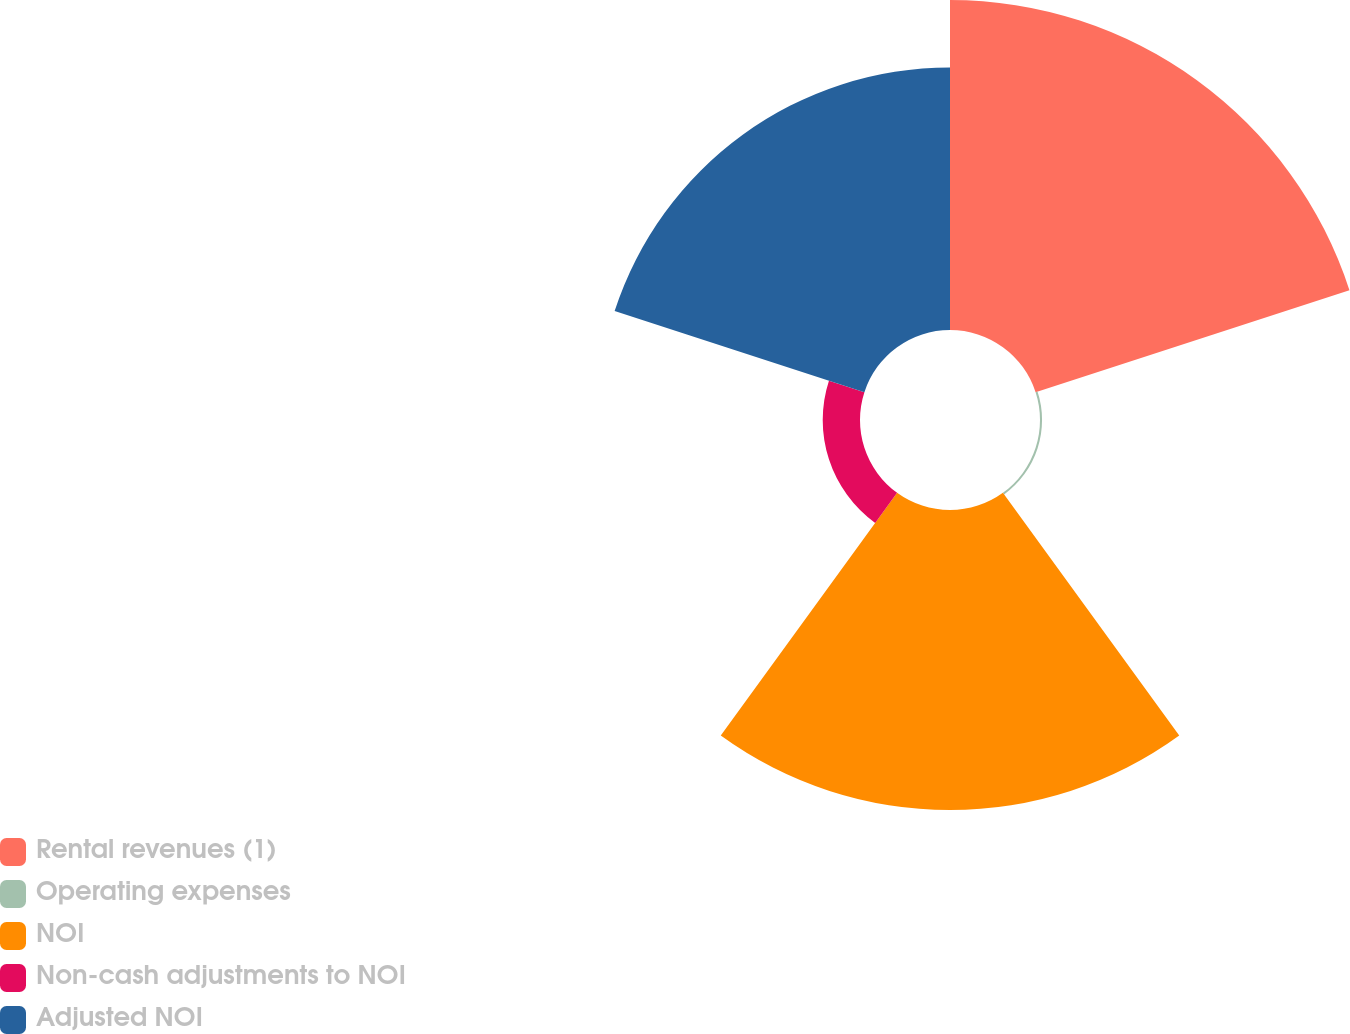Convert chart to OTSL. <chart><loc_0><loc_0><loc_500><loc_500><pie_chart><fcel>Rental revenues (1)<fcel>Operating expenses<fcel>NOI<fcel>Non-cash adjustments to NOI<fcel>Adjusted NOI<nl><fcel>35.41%<fcel>0.22%<fcel>32.19%<fcel>4.0%<fcel>28.18%<nl></chart> 